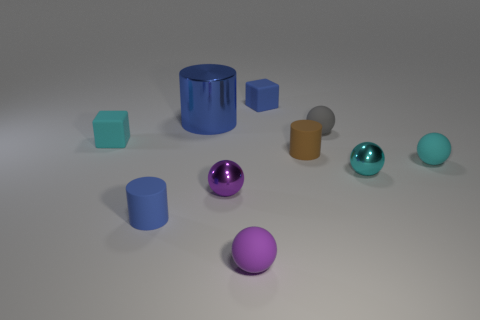Subtract all rubber cylinders. How many cylinders are left? 1 Subtract all gray balls. How many blue cylinders are left? 2 Subtract all cyan spheres. How many spheres are left? 3 Subtract 3 spheres. How many spheres are left? 2 Subtract all cubes. How many objects are left? 8 Subtract all brown balls. Subtract all brown cylinders. How many balls are left? 5 Subtract 0 brown balls. How many objects are left? 10 Subtract all large cylinders. Subtract all red rubber cylinders. How many objects are left? 9 Add 6 small cyan rubber balls. How many small cyan rubber balls are left? 7 Add 8 large yellow metal cubes. How many large yellow metal cubes exist? 8 